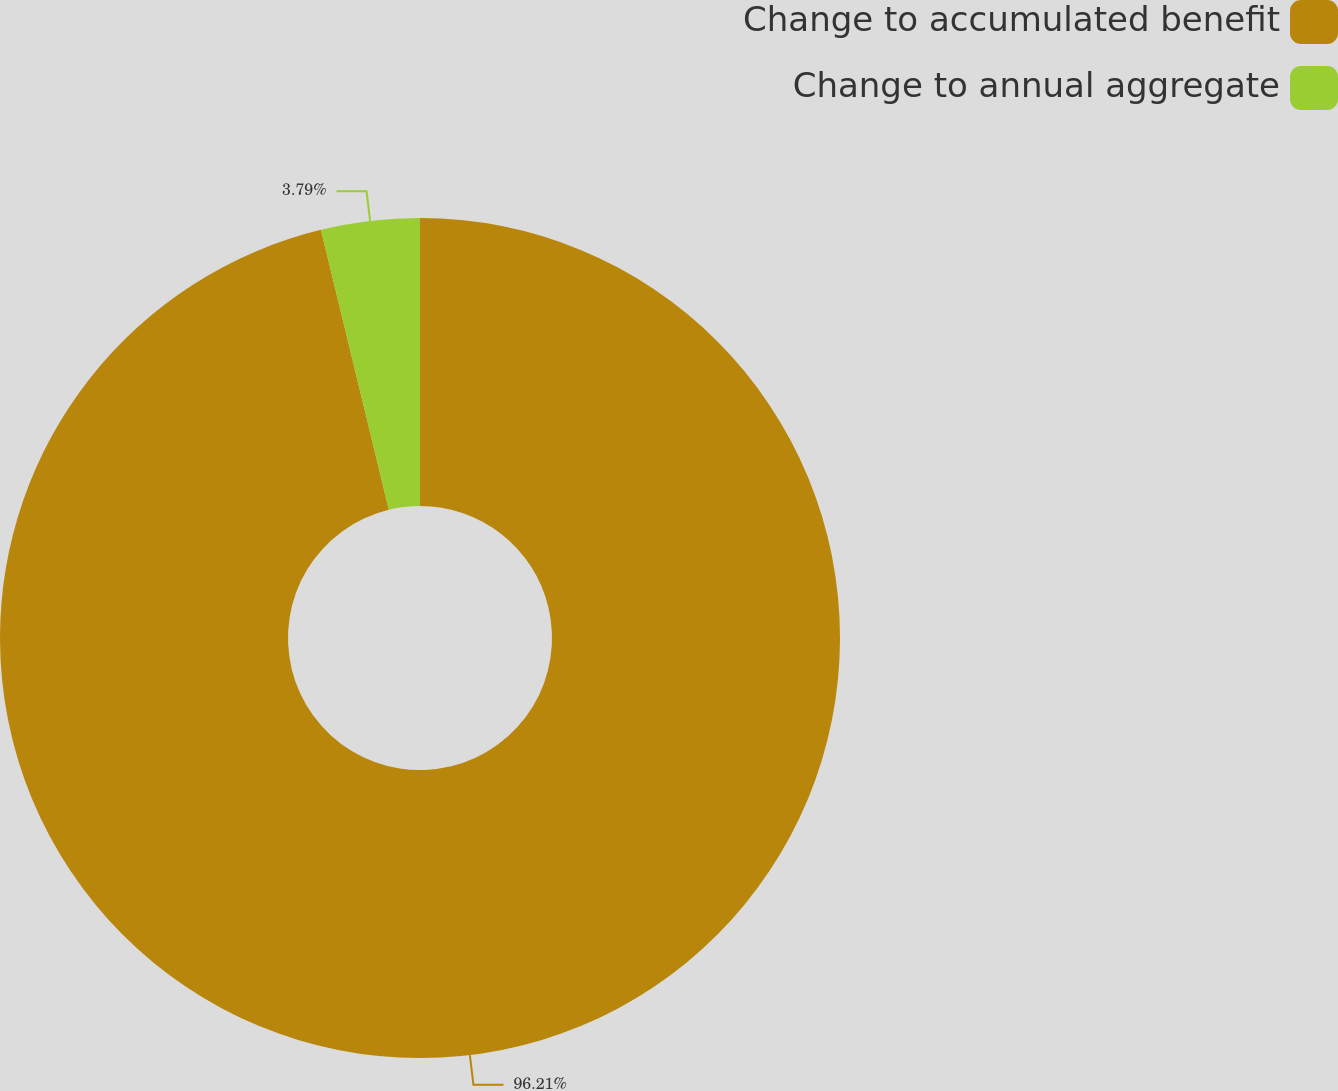Convert chart. <chart><loc_0><loc_0><loc_500><loc_500><pie_chart><fcel>Change to accumulated benefit<fcel>Change to annual aggregate<nl><fcel>96.21%<fcel>3.79%<nl></chart> 